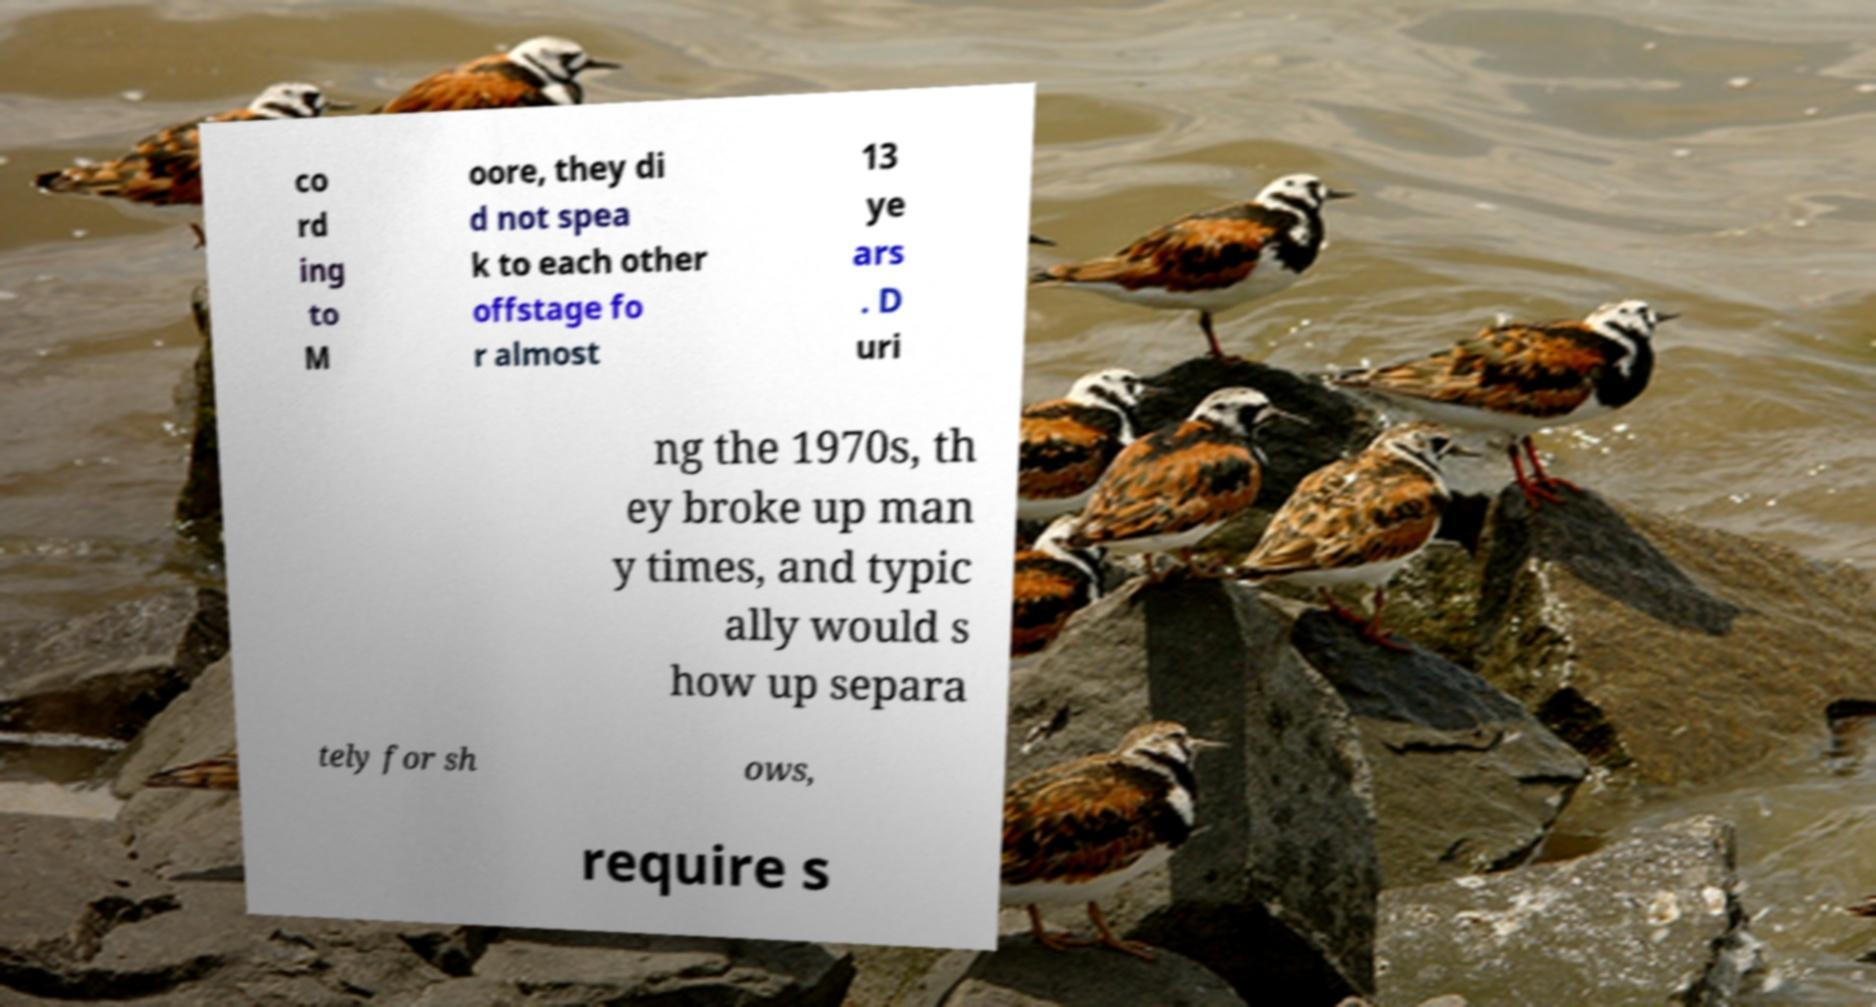For documentation purposes, I need the text within this image transcribed. Could you provide that? co rd ing to M oore, they di d not spea k to each other offstage fo r almost 13 ye ars . D uri ng the 1970s, th ey broke up man y times, and typic ally would s how up separa tely for sh ows, require s 